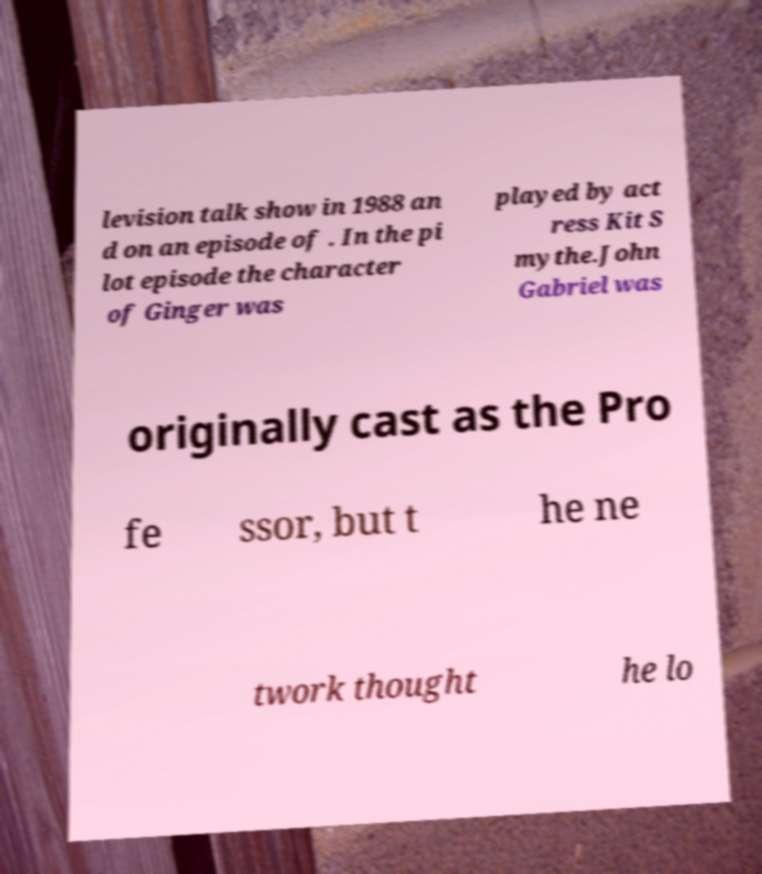Can you read and provide the text displayed in the image?This photo seems to have some interesting text. Can you extract and type it out for me? levision talk show in 1988 an d on an episode of . In the pi lot episode the character of Ginger was played by act ress Kit S mythe.John Gabriel was originally cast as the Pro fe ssor, but t he ne twork thought he lo 